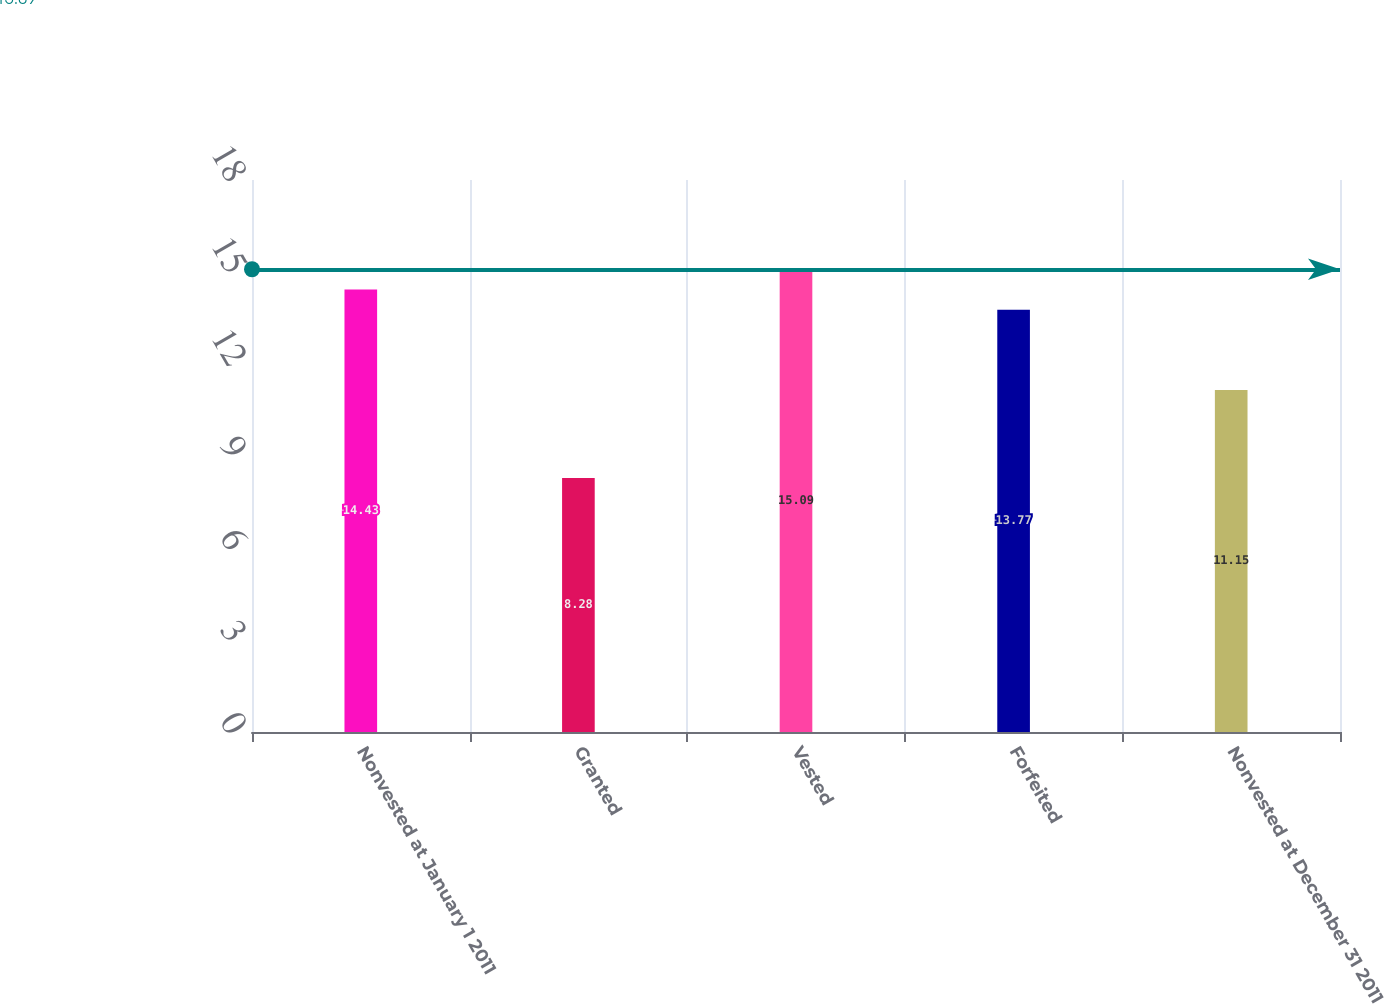Convert chart. <chart><loc_0><loc_0><loc_500><loc_500><bar_chart><fcel>Nonvested at January 1 2011<fcel>Granted<fcel>Vested<fcel>Forfeited<fcel>Nonvested at December 31 2011<nl><fcel>14.43<fcel>8.28<fcel>15.09<fcel>13.77<fcel>11.15<nl></chart> 